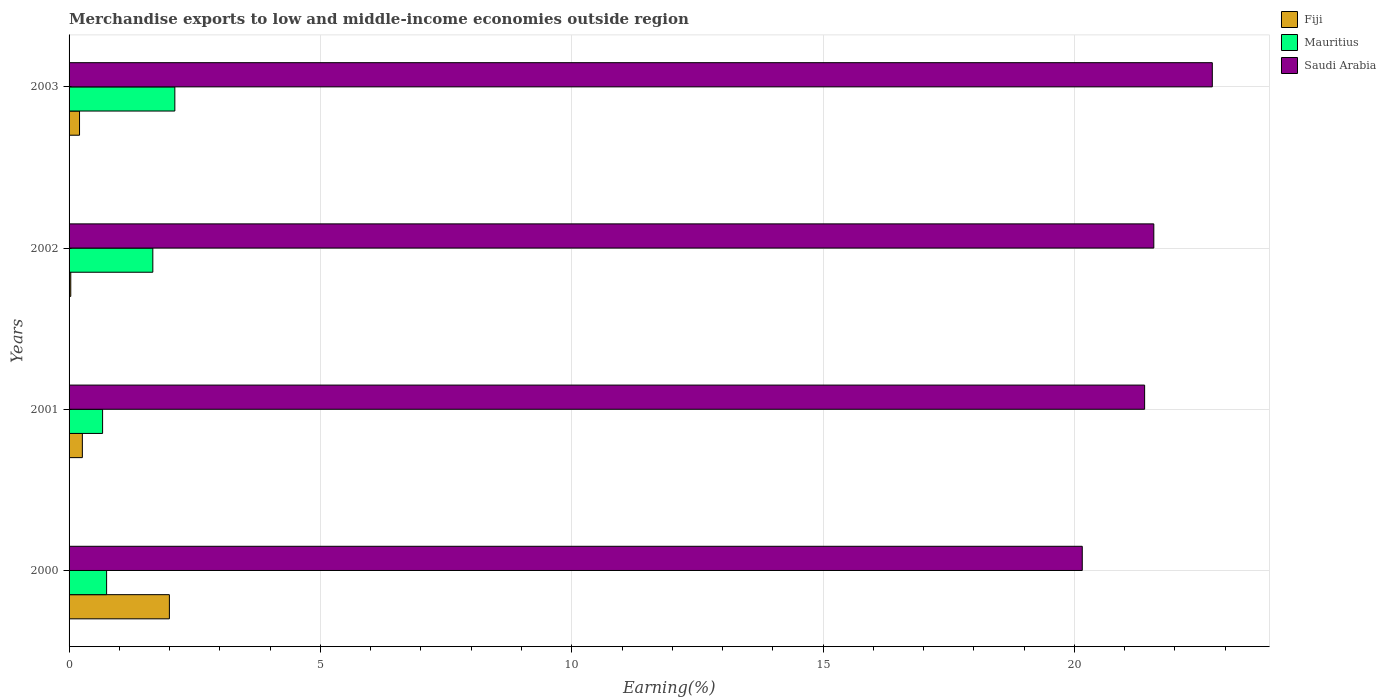Are the number of bars per tick equal to the number of legend labels?
Make the answer very short. Yes. Are the number of bars on each tick of the Y-axis equal?
Provide a short and direct response. Yes. How many bars are there on the 3rd tick from the top?
Give a very brief answer. 3. How many bars are there on the 1st tick from the bottom?
Your response must be concise. 3. What is the label of the 2nd group of bars from the top?
Provide a short and direct response. 2002. In how many cases, is the number of bars for a given year not equal to the number of legend labels?
Your answer should be compact. 0. What is the percentage of amount earned from merchandise exports in Mauritius in 2001?
Keep it short and to the point. 0.67. Across all years, what is the maximum percentage of amount earned from merchandise exports in Saudi Arabia?
Your response must be concise. 22.74. Across all years, what is the minimum percentage of amount earned from merchandise exports in Saudi Arabia?
Give a very brief answer. 20.16. In which year was the percentage of amount earned from merchandise exports in Saudi Arabia maximum?
Your response must be concise. 2003. In which year was the percentage of amount earned from merchandise exports in Mauritius minimum?
Your answer should be very brief. 2001. What is the total percentage of amount earned from merchandise exports in Saudi Arabia in the graph?
Offer a terse response. 85.88. What is the difference between the percentage of amount earned from merchandise exports in Saudi Arabia in 2001 and that in 2002?
Provide a succinct answer. -0.18. What is the difference between the percentage of amount earned from merchandise exports in Fiji in 2000 and the percentage of amount earned from merchandise exports in Mauritius in 2001?
Provide a short and direct response. 1.33. What is the average percentage of amount earned from merchandise exports in Saudi Arabia per year?
Keep it short and to the point. 21.47. In the year 2003, what is the difference between the percentage of amount earned from merchandise exports in Mauritius and percentage of amount earned from merchandise exports in Saudi Arabia?
Give a very brief answer. -20.64. What is the ratio of the percentage of amount earned from merchandise exports in Saudi Arabia in 2000 to that in 2002?
Provide a succinct answer. 0.93. What is the difference between the highest and the second highest percentage of amount earned from merchandise exports in Mauritius?
Offer a terse response. 0.44. What is the difference between the highest and the lowest percentage of amount earned from merchandise exports in Saudi Arabia?
Offer a very short reply. 2.59. In how many years, is the percentage of amount earned from merchandise exports in Mauritius greater than the average percentage of amount earned from merchandise exports in Mauritius taken over all years?
Provide a succinct answer. 2. Is the sum of the percentage of amount earned from merchandise exports in Saudi Arabia in 2000 and 2002 greater than the maximum percentage of amount earned from merchandise exports in Mauritius across all years?
Ensure brevity in your answer.  Yes. What does the 3rd bar from the top in 2002 represents?
Give a very brief answer. Fiji. What does the 1st bar from the bottom in 2000 represents?
Provide a short and direct response. Fiji. Is it the case that in every year, the sum of the percentage of amount earned from merchandise exports in Saudi Arabia and percentage of amount earned from merchandise exports in Fiji is greater than the percentage of amount earned from merchandise exports in Mauritius?
Your answer should be compact. Yes. What is the difference between two consecutive major ticks on the X-axis?
Your answer should be very brief. 5. Are the values on the major ticks of X-axis written in scientific E-notation?
Give a very brief answer. No. Does the graph contain any zero values?
Your response must be concise. No. Does the graph contain grids?
Provide a short and direct response. Yes. Where does the legend appear in the graph?
Ensure brevity in your answer.  Top right. How many legend labels are there?
Offer a very short reply. 3. What is the title of the graph?
Your answer should be very brief. Merchandise exports to low and middle-income economies outside region. Does "Panama" appear as one of the legend labels in the graph?
Your answer should be compact. No. What is the label or title of the X-axis?
Provide a short and direct response. Earning(%). What is the label or title of the Y-axis?
Your response must be concise. Years. What is the Earning(%) of Fiji in 2000?
Provide a short and direct response. 2. What is the Earning(%) in Mauritius in 2000?
Offer a very short reply. 0.75. What is the Earning(%) in Saudi Arabia in 2000?
Provide a short and direct response. 20.16. What is the Earning(%) of Fiji in 2001?
Provide a short and direct response. 0.26. What is the Earning(%) in Mauritius in 2001?
Offer a very short reply. 0.67. What is the Earning(%) in Saudi Arabia in 2001?
Keep it short and to the point. 21.4. What is the Earning(%) of Fiji in 2002?
Your answer should be compact. 0.03. What is the Earning(%) of Mauritius in 2002?
Give a very brief answer. 1.67. What is the Earning(%) in Saudi Arabia in 2002?
Keep it short and to the point. 21.58. What is the Earning(%) of Fiji in 2003?
Provide a succinct answer. 0.21. What is the Earning(%) of Mauritius in 2003?
Your answer should be very brief. 2.1. What is the Earning(%) in Saudi Arabia in 2003?
Your answer should be very brief. 22.74. Across all years, what is the maximum Earning(%) of Fiji?
Provide a succinct answer. 2. Across all years, what is the maximum Earning(%) of Mauritius?
Provide a short and direct response. 2.1. Across all years, what is the maximum Earning(%) in Saudi Arabia?
Provide a succinct answer. 22.74. Across all years, what is the minimum Earning(%) in Fiji?
Ensure brevity in your answer.  0.03. Across all years, what is the minimum Earning(%) in Mauritius?
Ensure brevity in your answer.  0.67. Across all years, what is the minimum Earning(%) of Saudi Arabia?
Offer a very short reply. 20.16. What is the total Earning(%) of Fiji in the graph?
Give a very brief answer. 2.5. What is the total Earning(%) in Mauritius in the graph?
Make the answer very short. 5.18. What is the total Earning(%) of Saudi Arabia in the graph?
Provide a succinct answer. 85.88. What is the difference between the Earning(%) in Fiji in 2000 and that in 2001?
Offer a terse response. 1.73. What is the difference between the Earning(%) in Mauritius in 2000 and that in 2001?
Your answer should be very brief. 0.08. What is the difference between the Earning(%) of Saudi Arabia in 2000 and that in 2001?
Provide a short and direct response. -1.24. What is the difference between the Earning(%) of Fiji in 2000 and that in 2002?
Provide a succinct answer. 1.96. What is the difference between the Earning(%) of Mauritius in 2000 and that in 2002?
Offer a very short reply. -0.92. What is the difference between the Earning(%) in Saudi Arabia in 2000 and that in 2002?
Your answer should be very brief. -1.42. What is the difference between the Earning(%) in Fiji in 2000 and that in 2003?
Offer a terse response. 1.79. What is the difference between the Earning(%) in Mauritius in 2000 and that in 2003?
Provide a succinct answer. -1.36. What is the difference between the Earning(%) of Saudi Arabia in 2000 and that in 2003?
Your answer should be compact. -2.59. What is the difference between the Earning(%) in Fiji in 2001 and that in 2002?
Your answer should be very brief. 0.23. What is the difference between the Earning(%) of Mauritius in 2001 and that in 2002?
Provide a short and direct response. -1. What is the difference between the Earning(%) of Saudi Arabia in 2001 and that in 2002?
Give a very brief answer. -0.18. What is the difference between the Earning(%) of Fiji in 2001 and that in 2003?
Your answer should be compact. 0.06. What is the difference between the Earning(%) of Mauritius in 2001 and that in 2003?
Make the answer very short. -1.44. What is the difference between the Earning(%) of Saudi Arabia in 2001 and that in 2003?
Make the answer very short. -1.35. What is the difference between the Earning(%) in Fiji in 2002 and that in 2003?
Keep it short and to the point. -0.17. What is the difference between the Earning(%) in Mauritius in 2002 and that in 2003?
Make the answer very short. -0.44. What is the difference between the Earning(%) in Saudi Arabia in 2002 and that in 2003?
Keep it short and to the point. -1.16. What is the difference between the Earning(%) in Fiji in 2000 and the Earning(%) in Mauritius in 2001?
Keep it short and to the point. 1.33. What is the difference between the Earning(%) of Fiji in 2000 and the Earning(%) of Saudi Arabia in 2001?
Your answer should be compact. -19.4. What is the difference between the Earning(%) of Mauritius in 2000 and the Earning(%) of Saudi Arabia in 2001?
Your response must be concise. -20.65. What is the difference between the Earning(%) of Fiji in 2000 and the Earning(%) of Mauritius in 2002?
Offer a very short reply. 0.33. What is the difference between the Earning(%) of Fiji in 2000 and the Earning(%) of Saudi Arabia in 2002?
Your answer should be very brief. -19.58. What is the difference between the Earning(%) in Mauritius in 2000 and the Earning(%) in Saudi Arabia in 2002?
Your answer should be compact. -20.83. What is the difference between the Earning(%) of Fiji in 2000 and the Earning(%) of Mauritius in 2003?
Provide a short and direct response. -0.11. What is the difference between the Earning(%) in Fiji in 2000 and the Earning(%) in Saudi Arabia in 2003?
Make the answer very short. -20.75. What is the difference between the Earning(%) of Mauritius in 2000 and the Earning(%) of Saudi Arabia in 2003?
Ensure brevity in your answer.  -22. What is the difference between the Earning(%) in Fiji in 2001 and the Earning(%) in Mauritius in 2002?
Offer a terse response. -1.4. What is the difference between the Earning(%) of Fiji in 2001 and the Earning(%) of Saudi Arabia in 2002?
Your response must be concise. -21.32. What is the difference between the Earning(%) of Mauritius in 2001 and the Earning(%) of Saudi Arabia in 2002?
Offer a terse response. -20.91. What is the difference between the Earning(%) in Fiji in 2001 and the Earning(%) in Mauritius in 2003?
Your response must be concise. -1.84. What is the difference between the Earning(%) of Fiji in 2001 and the Earning(%) of Saudi Arabia in 2003?
Keep it short and to the point. -22.48. What is the difference between the Earning(%) in Mauritius in 2001 and the Earning(%) in Saudi Arabia in 2003?
Keep it short and to the point. -22.08. What is the difference between the Earning(%) in Fiji in 2002 and the Earning(%) in Mauritius in 2003?
Make the answer very short. -2.07. What is the difference between the Earning(%) in Fiji in 2002 and the Earning(%) in Saudi Arabia in 2003?
Offer a terse response. -22.71. What is the difference between the Earning(%) of Mauritius in 2002 and the Earning(%) of Saudi Arabia in 2003?
Provide a succinct answer. -21.08. What is the average Earning(%) of Fiji per year?
Provide a short and direct response. 0.63. What is the average Earning(%) of Mauritius per year?
Give a very brief answer. 1.3. What is the average Earning(%) of Saudi Arabia per year?
Your answer should be compact. 21.47. In the year 2000, what is the difference between the Earning(%) of Fiji and Earning(%) of Mauritius?
Give a very brief answer. 1.25. In the year 2000, what is the difference between the Earning(%) of Fiji and Earning(%) of Saudi Arabia?
Provide a short and direct response. -18.16. In the year 2000, what is the difference between the Earning(%) in Mauritius and Earning(%) in Saudi Arabia?
Offer a very short reply. -19.41. In the year 2001, what is the difference between the Earning(%) in Fiji and Earning(%) in Mauritius?
Your response must be concise. -0.4. In the year 2001, what is the difference between the Earning(%) of Fiji and Earning(%) of Saudi Arabia?
Your answer should be compact. -21.13. In the year 2001, what is the difference between the Earning(%) of Mauritius and Earning(%) of Saudi Arabia?
Ensure brevity in your answer.  -20.73. In the year 2002, what is the difference between the Earning(%) of Fiji and Earning(%) of Mauritius?
Your answer should be very brief. -1.63. In the year 2002, what is the difference between the Earning(%) of Fiji and Earning(%) of Saudi Arabia?
Your answer should be very brief. -21.55. In the year 2002, what is the difference between the Earning(%) in Mauritius and Earning(%) in Saudi Arabia?
Make the answer very short. -19.91. In the year 2003, what is the difference between the Earning(%) in Fiji and Earning(%) in Mauritius?
Ensure brevity in your answer.  -1.9. In the year 2003, what is the difference between the Earning(%) in Fiji and Earning(%) in Saudi Arabia?
Provide a succinct answer. -22.54. In the year 2003, what is the difference between the Earning(%) in Mauritius and Earning(%) in Saudi Arabia?
Ensure brevity in your answer.  -20.64. What is the ratio of the Earning(%) in Fiji in 2000 to that in 2001?
Give a very brief answer. 7.55. What is the ratio of the Earning(%) in Mauritius in 2000 to that in 2001?
Ensure brevity in your answer.  1.12. What is the ratio of the Earning(%) of Saudi Arabia in 2000 to that in 2001?
Make the answer very short. 0.94. What is the ratio of the Earning(%) in Fiji in 2000 to that in 2002?
Provide a succinct answer. 59.01. What is the ratio of the Earning(%) of Mauritius in 2000 to that in 2002?
Your answer should be compact. 0.45. What is the ratio of the Earning(%) in Saudi Arabia in 2000 to that in 2002?
Offer a very short reply. 0.93. What is the ratio of the Earning(%) in Fiji in 2000 to that in 2003?
Provide a short and direct response. 9.58. What is the ratio of the Earning(%) in Mauritius in 2000 to that in 2003?
Your answer should be very brief. 0.35. What is the ratio of the Earning(%) in Saudi Arabia in 2000 to that in 2003?
Your response must be concise. 0.89. What is the ratio of the Earning(%) of Fiji in 2001 to that in 2002?
Provide a short and direct response. 7.82. What is the ratio of the Earning(%) in Mauritius in 2001 to that in 2002?
Provide a short and direct response. 0.4. What is the ratio of the Earning(%) in Fiji in 2001 to that in 2003?
Give a very brief answer. 1.27. What is the ratio of the Earning(%) of Mauritius in 2001 to that in 2003?
Provide a short and direct response. 0.32. What is the ratio of the Earning(%) in Saudi Arabia in 2001 to that in 2003?
Offer a terse response. 0.94. What is the ratio of the Earning(%) of Fiji in 2002 to that in 2003?
Ensure brevity in your answer.  0.16. What is the ratio of the Earning(%) in Mauritius in 2002 to that in 2003?
Your answer should be very brief. 0.79. What is the ratio of the Earning(%) of Saudi Arabia in 2002 to that in 2003?
Provide a short and direct response. 0.95. What is the difference between the highest and the second highest Earning(%) in Fiji?
Keep it short and to the point. 1.73. What is the difference between the highest and the second highest Earning(%) of Mauritius?
Offer a very short reply. 0.44. What is the difference between the highest and the second highest Earning(%) of Saudi Arabia?
Provide a succinct answer. 1.16. What is the difference between the highest and the lowest Earning(%) of Fiji?
Give a very brief answer. 1.96. What is the difference between the highest and the lowest Earning(%) of Mauritius?
Give a very brief answer. 1.44. What is the difference between the highest and the lowest Earning(%) in Saudi Arabia?
Your answer should be very brief. 2.59. 